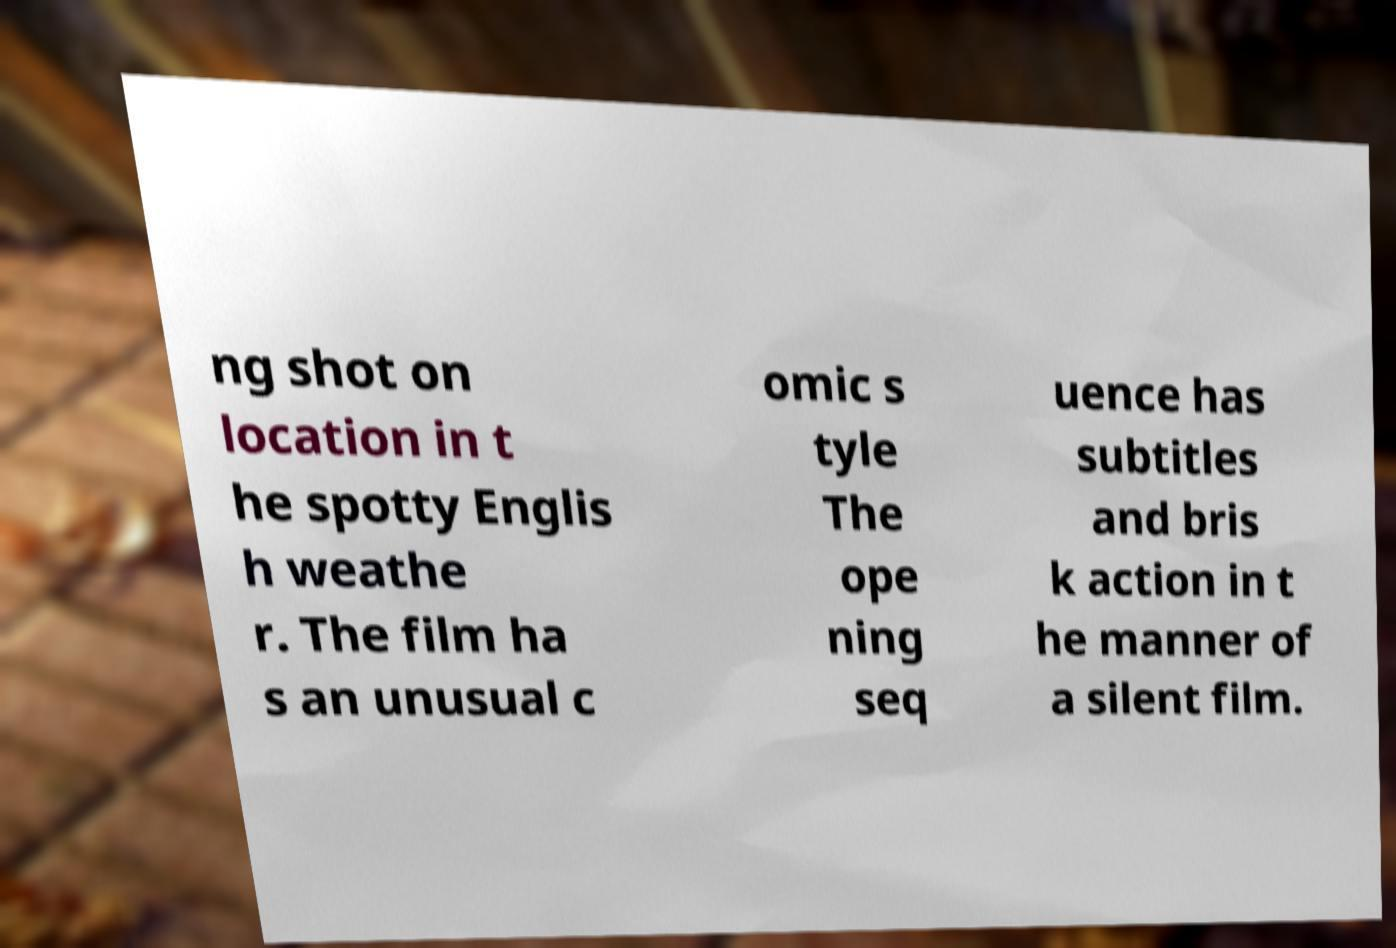Could you extract and type out the text from this image? ng shot on location in t he spotty Englis h weathe r. The film ha s an unusual c omic s tyle The ope ning seq uence has subtitles and bris k action in t he manner of a silent film. 